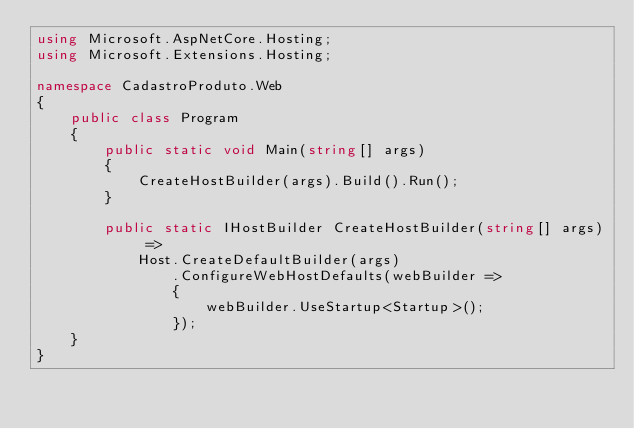Convert code to text. <code><loc_0><loc_0><loc_500><loc_500><_C#_>using Microsoft.AspNetCore.Hosting;
using Microsoft.Extensions.Hosting;

namespace CadastroProduto.Web
{
    public class Program
    {
        public static void Main(string[] args)
        {
            CreateHostBuilder(args).Build().Run();
        }

        public static IHostBuilder CreateHostBuilder(string[] args) =>
            Host.CreateDefaultBuilder(args)
                .ConfigureWebHostDefaults(webBuilder =>
                {
                    webBuilder.UseStartup<Startup>();
                });
    }
}
</code> 